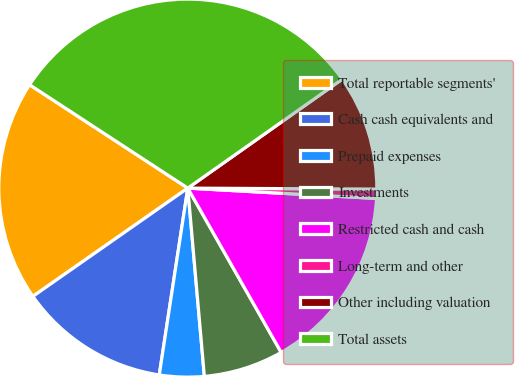<chart> <loc_0><loc_0><loc_500><loc_500><pie_chart><fcel>Total reportable segments'<fcel>Cash cash equivalents and<fcel>Prepaid expenses<fcel>Investments<fcel>Restricted cash and cash<fcel>Long-term and other<fcel>Other including valuation<fcel>Total assets<nl><fcel>18.92%<fcel>12.88%<fcel>3.81%<fcel>6.83%<fcel>15.9%<fcel>0.79%<fcel>9.86%<fcel>31.01%<nl></chart> 